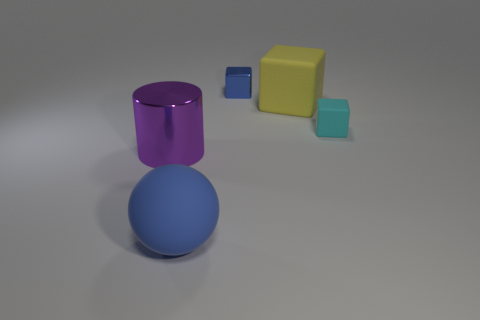What is the color of the tiny thing on the left side of the tiny cyan matte block that is behind the ball?
Your answer should be compact. Blue. There is a blue thing that is the same shape as the big yellow object; what is its material?
Ensure brevity in your answer.  Metal. There is a small cube in front of the tiny thing that is to the left of the matte thing that is right of the yellow thing; what is its color?
Keep it short and to the point. Cyan. How many objects are big yellow blocks or large blue spheres?
Provide a short and direct response. 2. How many big rubber things have the same shape as the small blue metallic object?
Keep it short and to the point. 1. Is the small cyan cube made of the same material as the tiny cube behind the small cyan rubber object?
Your answer should be very brief. No. What size is the ball that is made of the same material as the cyan thing?
Keep it short and to the point. Large. There is a blue thing in front of the small blue block; what is its size?
Your response must be concise. Large. What number of purple things are the same size as the cylinder?
Your response must be concise. 0. What is the size of the rubber thing that is the same color as the tiny metal block?
Keep it short and to the point. Large. 